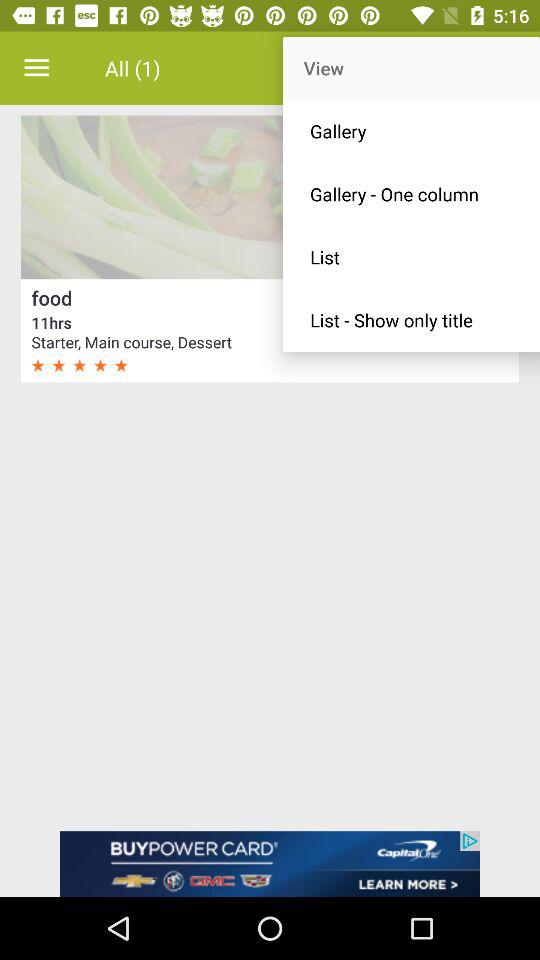What is the rating of the "Starter, Main course, Dessert"? The rating is 5 stars. 